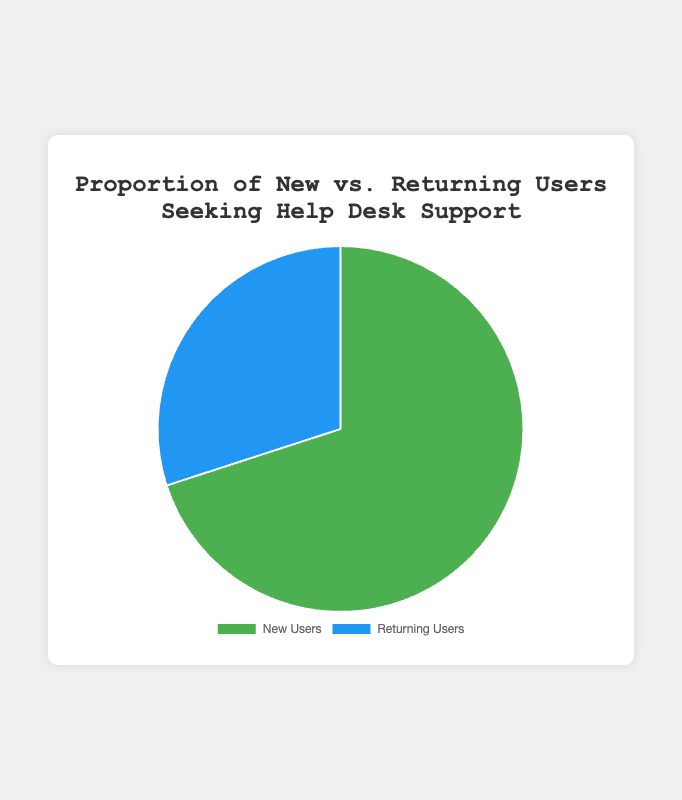What is the proportion of new users compared to returning users? To find the proportion, compare the counts of new users and returning users. There are 350 new users and 150 returning users. Therefore, the ratio of new users to returning users is 350:150, which simplifies to approximately 2.33:1.
Answer: 2.33:1 Which user group is larger, new users or returning users? By looking at the data, new users have a count of 350, and returning users have a count of 150. Since 350 is greater than 150, new users make up the larger group.
Answer: New users What percentage of the total users are returning users? First, calculate the total number of users: 350 (new) + 150 (returning) = 500 users. Then, find the percentage of returning users: (150 / 500) * 100 = 30%.
Answer: 30% What percentage of the total users are new users? First, calculate the total number of users: 350 (new) + 150 (returning) = 500 users. Then, find the percentage of new users: (350 / 500) * 100 = 70%.
Answer: 70% How many more new users are there than returning users? There are 350 new users and 150 returning users. The difference is 350 - 150 = 200.
Answer: 200 What color represents the returning users on the pie chart? By referring to the data used in the pie chart, returning users are represented by the color blue.
Answer: Blue If we combined the counts of new and returning users, what would the total be? Adding the counts of new users and returning users: 350 + 150 = 500.
Answer: 500 Is the number of returning users less than half of the number of new users? Calculate half of the new users: 350 / 2 = 175. The number of returning users is 150, which is less than 175.
Answer: Yes What fraction of the users are new users? There are 350 new users out of a total of 500 users. The fraction is 350 / 500, which simplifies to 7/10.
Answer: 7/10 